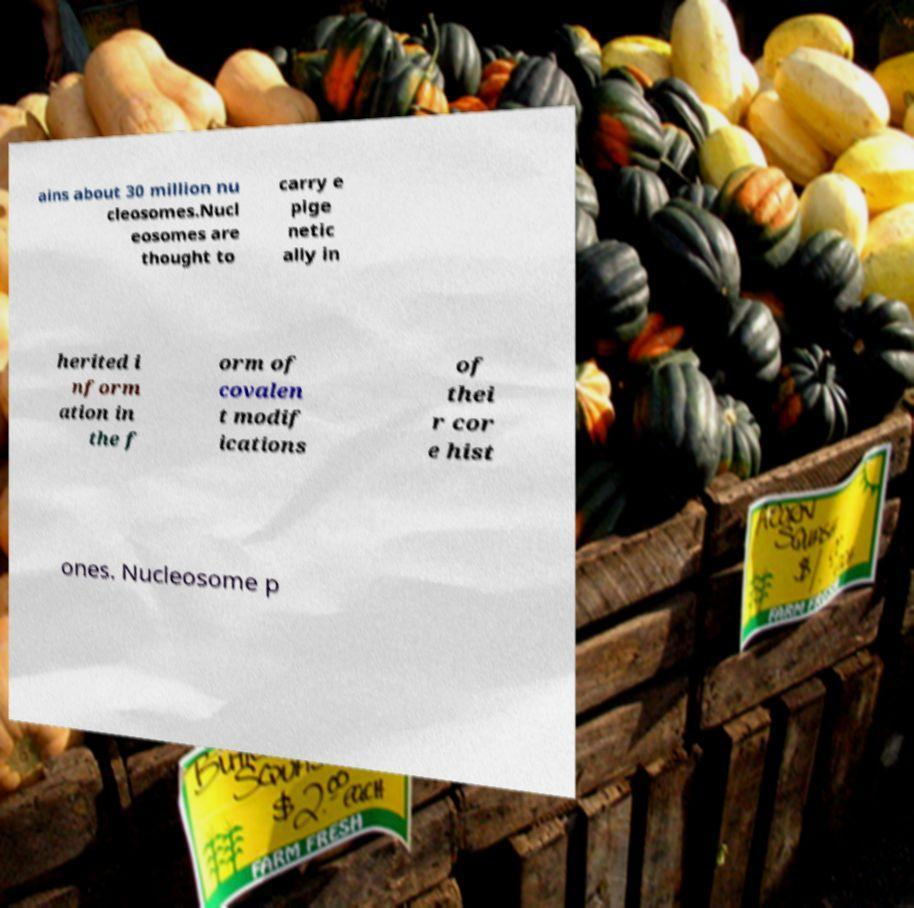There's text embedded in this image that I need extracted. Can you transcribe it verbatim? ains about 30 million nu cleosomes.Nucl eosomes are thought to carry e pige netic ally in herited i nform ation in the f orm of covalen t modif ications of thei r cor e hist ones. Nucleosome p 